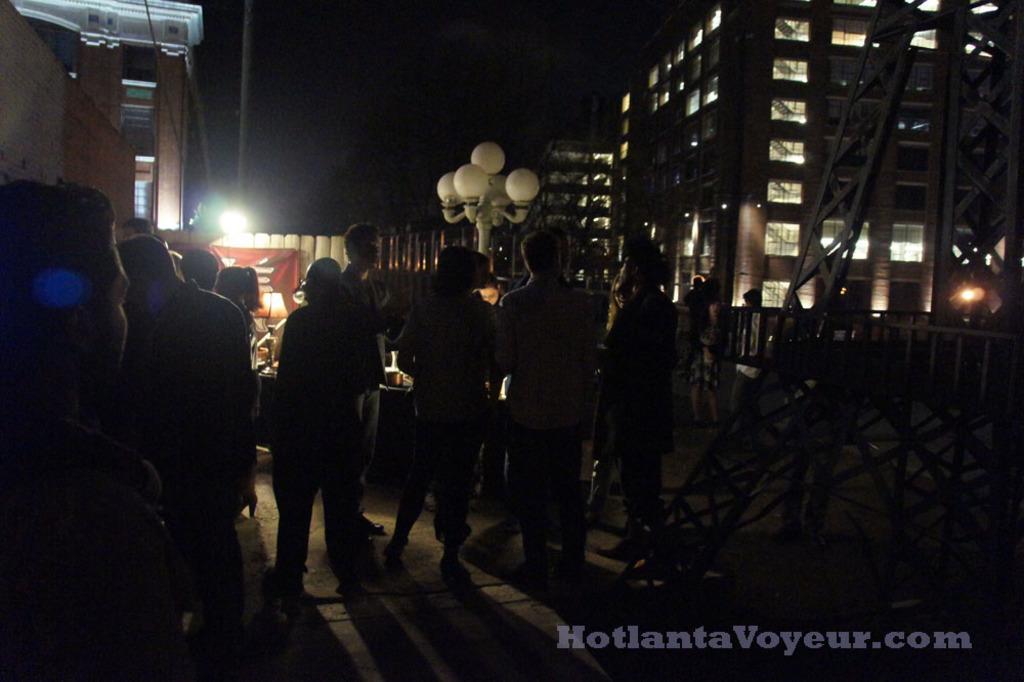How would you summarize this image in a sentence or two? In the foreground I can see a crowd, table, poles, metal rods and a text on the road. In the background I can see buildings and the sky. This image is taken may be during night. 